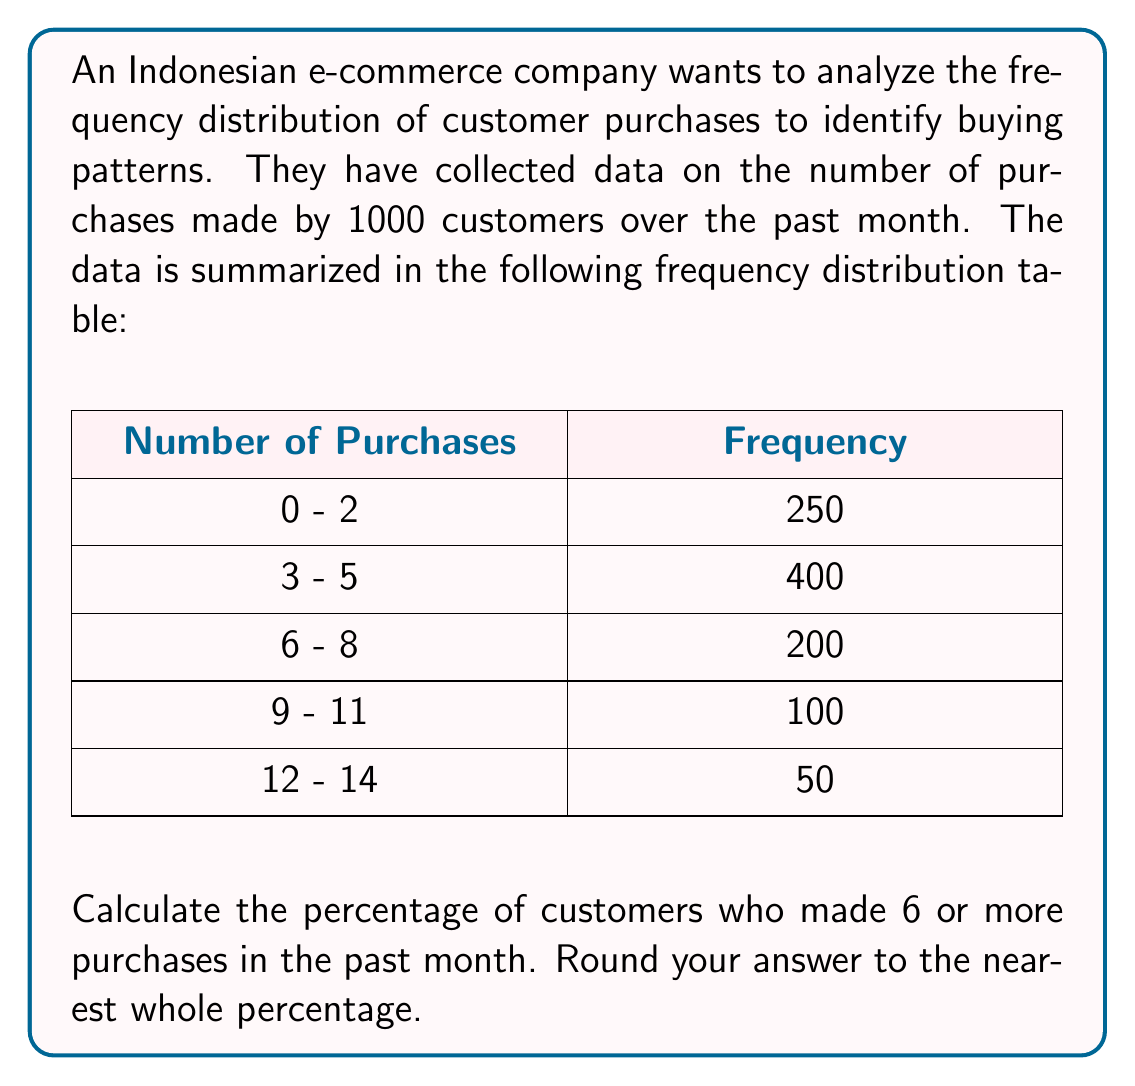Help me with this question. To solve this problem, we need to follow these steps:

1. Identify the classes that represent 6 or more purchases:
   These are the classes: 6-8, 9-11, and 12-14

2. Sum the frequencies for these classes:
   $200 + 100 + 50 = 350$

3. Calculate the total number of customers:
   $250 + 400 + 200 + 100 + 50 = 1000$

4. Calculate the percentage:
   $$\text{Percentage} = \frac{\text{Number of customers with 6 or more purchases}}{\text{Total number of customers}} \times 100\%$$
   
   $$\text{Percentage} = \frac{350}{1000} \times 100\% = 35\%$$

5. The question asks to round to the nearest whole percentage, but 35% is already a whole number, so no further rounding is necessary.

This analysis shows that 35% of the customers made 6 or more purchases in the past month, which is a significant portion of the customer base. This insight can be used to tailor marketing strategies, such as creating loyalty programs or targeted promotions for frequent buyers.
Answer: 35% 